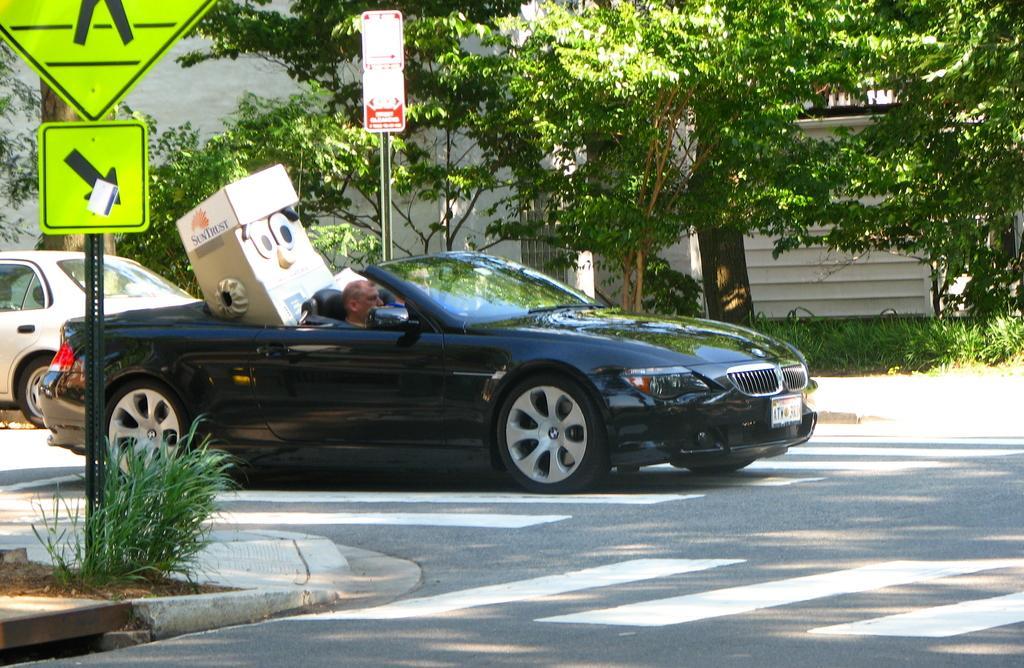How would you summarize this image in a sentence or two? In this image I see 2 cars which are on the road and I see 2 sign boards and I can also see that there are few plants and the trees. 